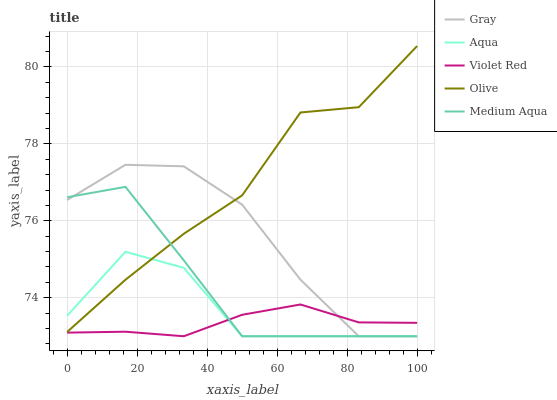Does Gray have the minimum area under the curve?
Answer yes or no. No. Does Gray have the maximum area under the curve?
Answer yes or no. No. Is Gray the smoothest?
Answer yes or no. No. Is Gray the roughest?
Answer yes or no. No. Does Gray have the highest value?
Answer yes or no. No. Is Violet Red less than Olive?
Answer yes or no. Yes. Is Olive greater than Violet Red?
Answer yes or no. Yes. Does Violet Red intersect Olive?
Answer yes or no. No. 